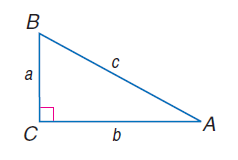Answer the mathemtical geometry problem and directly provide the correct option letter.
Question: a = 14, b = 48, and c = 50, find \cos B.
Choices: A: 0.02 B: 0.28 C: 0.48 D: 0.62 B 